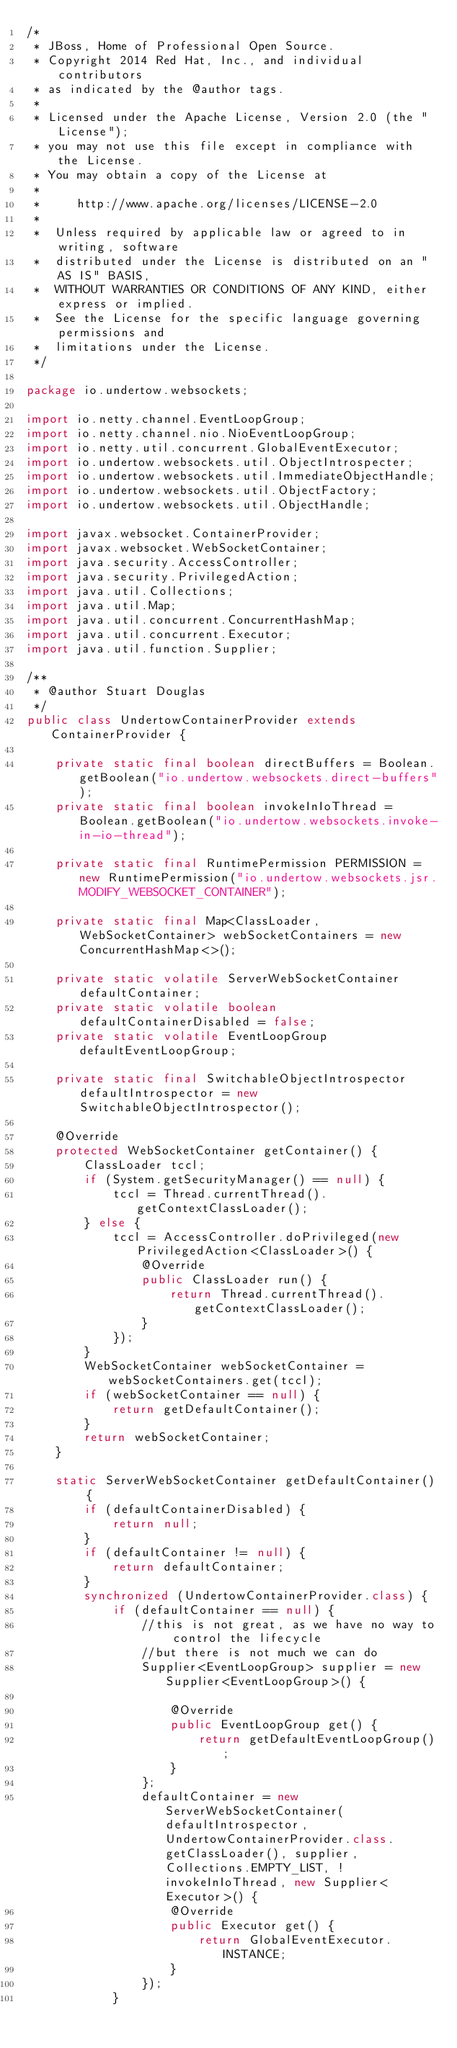<code> <loc_0><loc_0><loc_500><loc_500><_Java_>/*
 * JBoss, Home of Professional Open Source.
 * Copyright 2014 Red Hat, Inc., and individual contributors
 * as indicated by the @author tags.
 *
 * Licensed under the Apache License, Version 2.0 (the "License");
 * you may not use this file except in compliance with the License.
 * You may obtain a copy of the License at
 *
 *     http://www.apache.org/licenses/LICENSE-2.0
 *
 *  Unless required by applicable law or agreed to in writing, software
 *  distributed under the License is distributed on an "AS IS" BASIS,
 *  WITHOUT WARRANTIES OR CONDITIONS OF ANY KIND, either express or implied.
 *  See the License for the specific language governing permissions and
 *  limitations under the License.
 */

package io.undertow.websockets;

import io.netty.channel.EventLoopGroup;
import io.netty.channel.nio.NioEventLoopGroup;
import io.netty.util.concurrent.GlobalEventExecutor;
import io.undertow.websockets.util.ObjectIntrospecter;
import io.undertow.websockets.util.ImmediateObjectHandle;
import io.undertow.websockets.util.ObjectFactory;
import io.undertow.websockets.util.ObjectHandle;

import javax.websocket.ContainerProvider;
import javax.websocket.WebSocketContainer;
import java.security.AccessController;
import java.security.PrivilegedAction;
import java.util.Collections;
import java.util.Map;
import java.util.concurrent.ConcurrentHashMap;
import java.util.concurrent.Executor;
import java.util.function.Supplier;

/**
 * @author Stuart Douglas
 */
public class UndertowContainerProvider extends ContainerProvider {

    private static final boolean directBuffers = Boolean.getBoolean("io.undertow.websockets.direct-buffers");
    private static final boolean invokeInIoThread = Boolean.getBoolean("io.undertow.websockets.invoke-in-io-thread");

    private static final RuntimePermission PERMISSION = new RuntimePermission("io.undertow.websockets.jsr.MODIFY_WEBSOCKET_CONTAINER");

    private static final Map<ClassLoader, WebSocketContainer> webSocketContainers = new ConcurrentHashMap<>();

    private static volatile ServerWebSocketContainer defaultContainer;
    private static volatile boolean defaultContainerDisabled = false;
    private static volatile EventLoopGroup defaultEventLoopGroup;

    private static final SwitchableObjectIntrospector defaultIntrospector = new SwitchableObjectIntrospector();

    @Override
    protected WebSocketContainer getContainer() {
        ClassLoader tccl;
        if (System.getSecurityManager() == null) {
            tccl = Thread.currentThread().getContextClassLoader();
        } else {
            tccl = AccessController.doPrivileged(new PrivilegedAction<ClassLoader>() {
                @Override
                public ClassLoader run() {
                    return Thread.currentThread().getContextClassLoader();
                }
            });
        }
        WebSocketContainer webSocketContainer = webSocketContainers.get(tccl);
        if (webSocketContainer == null) {
            return getDefaultContainer();
        }
        return webSocketContainer;
    }

    static ServerWebSocketContainer getDefaultContainer() {
        if (defaultContainerDisabled) {
            return null;
        }
        if (defaultContainer != null) {
            return defaultContainer;
        }
        synchronized (UndertowContainerProvider.class) {
            if (defaultContainer == null) {
                //this is not great, as we have no way to control the lifecycle
                //but there is not much we can do
                Supplier<EventLoopGroup> supplier = new Supplier<EventLoopGroup>() {

                    @Override
                    public EventLoopGroup get() {
                        return getDefaultEventLoopGroup();
                    }
                };
                defaultContainer = new ServerWebSocketContainer(defaultIntrospector, UndertowContainerProvider.class.getClassLoader(), supplier, Collections.EMPTY_LIST, !invokeInIoThread, new Supplier<Executor>() {
                    @Override
                    public Executor get() {
                        return GlobalEventExecutor.INSTANCE;
                    }
                });
            }</code> 